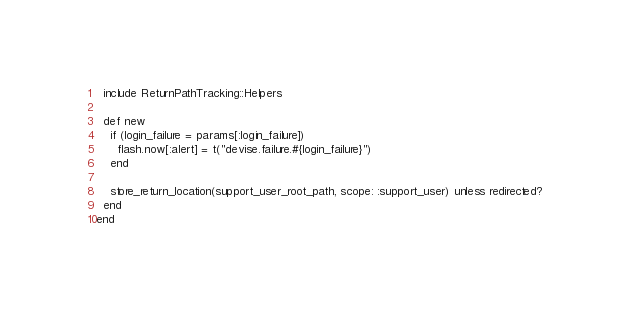<code> <loc_0><loc_0><loc_500><loc_500><_Ruby_>  include ReturnPathTracking::Helpers

  def new
    if (login_failure = params[:login_failure])
      flash.now[:alert] = t("devise.failure.#{login_failure}")
    end

    store_return_location(support_user_root_path, scope: :support_user) unless redirected?
  end
end
</code> 